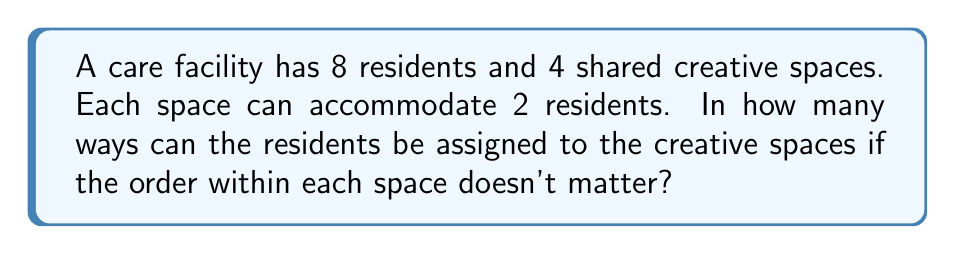Provide a solution to this math problem. Let's approach this step-by-step:

1) This is a partition problem, where we need to divide 8 residents into 4 groups of 2.

2) We can use the formula for the number of ways to partition n distinct objects into k groups, where $n_1, n_2, ..., n_k$ are the sizes of the groups:

   $$\frac{n!}{n_1! \cdot n_2! \cdot ... \cdot n_k! \cdot k!}$$

3) In our case:
   $n = 8$ (total residents)
   $k = 4$ (number of spaces)
   $n_1 = n_2 = n_3 = n_4 = 2$ (2 residents per space)

4) Substituting into the formula:

   $$\frac{8!}{(2!)^4 \cdot 4!}$$

5) Simplify:
   $$\frac{8 \cdot 7 \cdot 6 \cdot 5 \cdot 4!}{(2 \cdot 1)^4 \cdot 4!}$$

6) The 4! cancels out in the numerator and denominator:

   $$\frac{8 \cdot 7 \cdot 6 \cdot 5}{16}$$

7) Calculate:
   $$\frac{1680}{16} = 105$$

Therefore, there are 105 ways to assign the residents to the creative spaces.
Answer: 105 